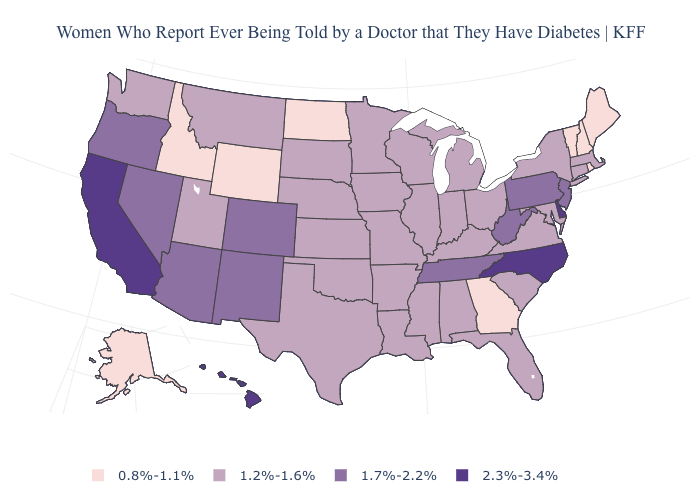What is the highest value in the USA?
Quick response, please. 2.3%-3.4%. What is the highest value in the USA?
Keep it brief. 2.3%-3.4%. Name the states that have a value in the range 0.8%-1.1%?
Write a very short answer. Alaska, Georgia, Idaho, Maine, New Hampshire, North Dakota, Rhode Island, Vermont, Wyoming. Which states hav the highest value in the Northeast?
Give a very brief answer. New Jersey, Pennsylvania. What is the value of Utah?
Write a very short answer. 1.2%-1.6%. Name the states that have a value in the range 2.3%-3.4%?
Answer briefly. California, Delaware, Hawaii, North Carolina. What is the value of Wyoming?
Give a very brief answer. 0.8%-1.1%. What is the lowest value in the USA?
Concise answer only. 0.8%-1.1%. Name the states that have a value in the range 0.8%-1.1%?
Short answer required. Alaska, Georgia, Idaho, Maine, New Hampshire, North Dakota, Rhode Island, Vermont, Wyoming. Among the states that border Nebraska , which have the lowest value?
Give a very brief answer. Wyoming. Does New Jersey have the highest value in the Northeast?
Be succinct. Yes. What is the lowest value in the Northeast?
Be succinct. 0.8%-1.1%. What is the value of Michigan?
Write a very short answer. 1.2%-1.6%. What is the value of Pennsylvania?
Keep it brief. 1.7%-2.2%. What is the value of California?
Short answer required. 2.3%-3.4%. 